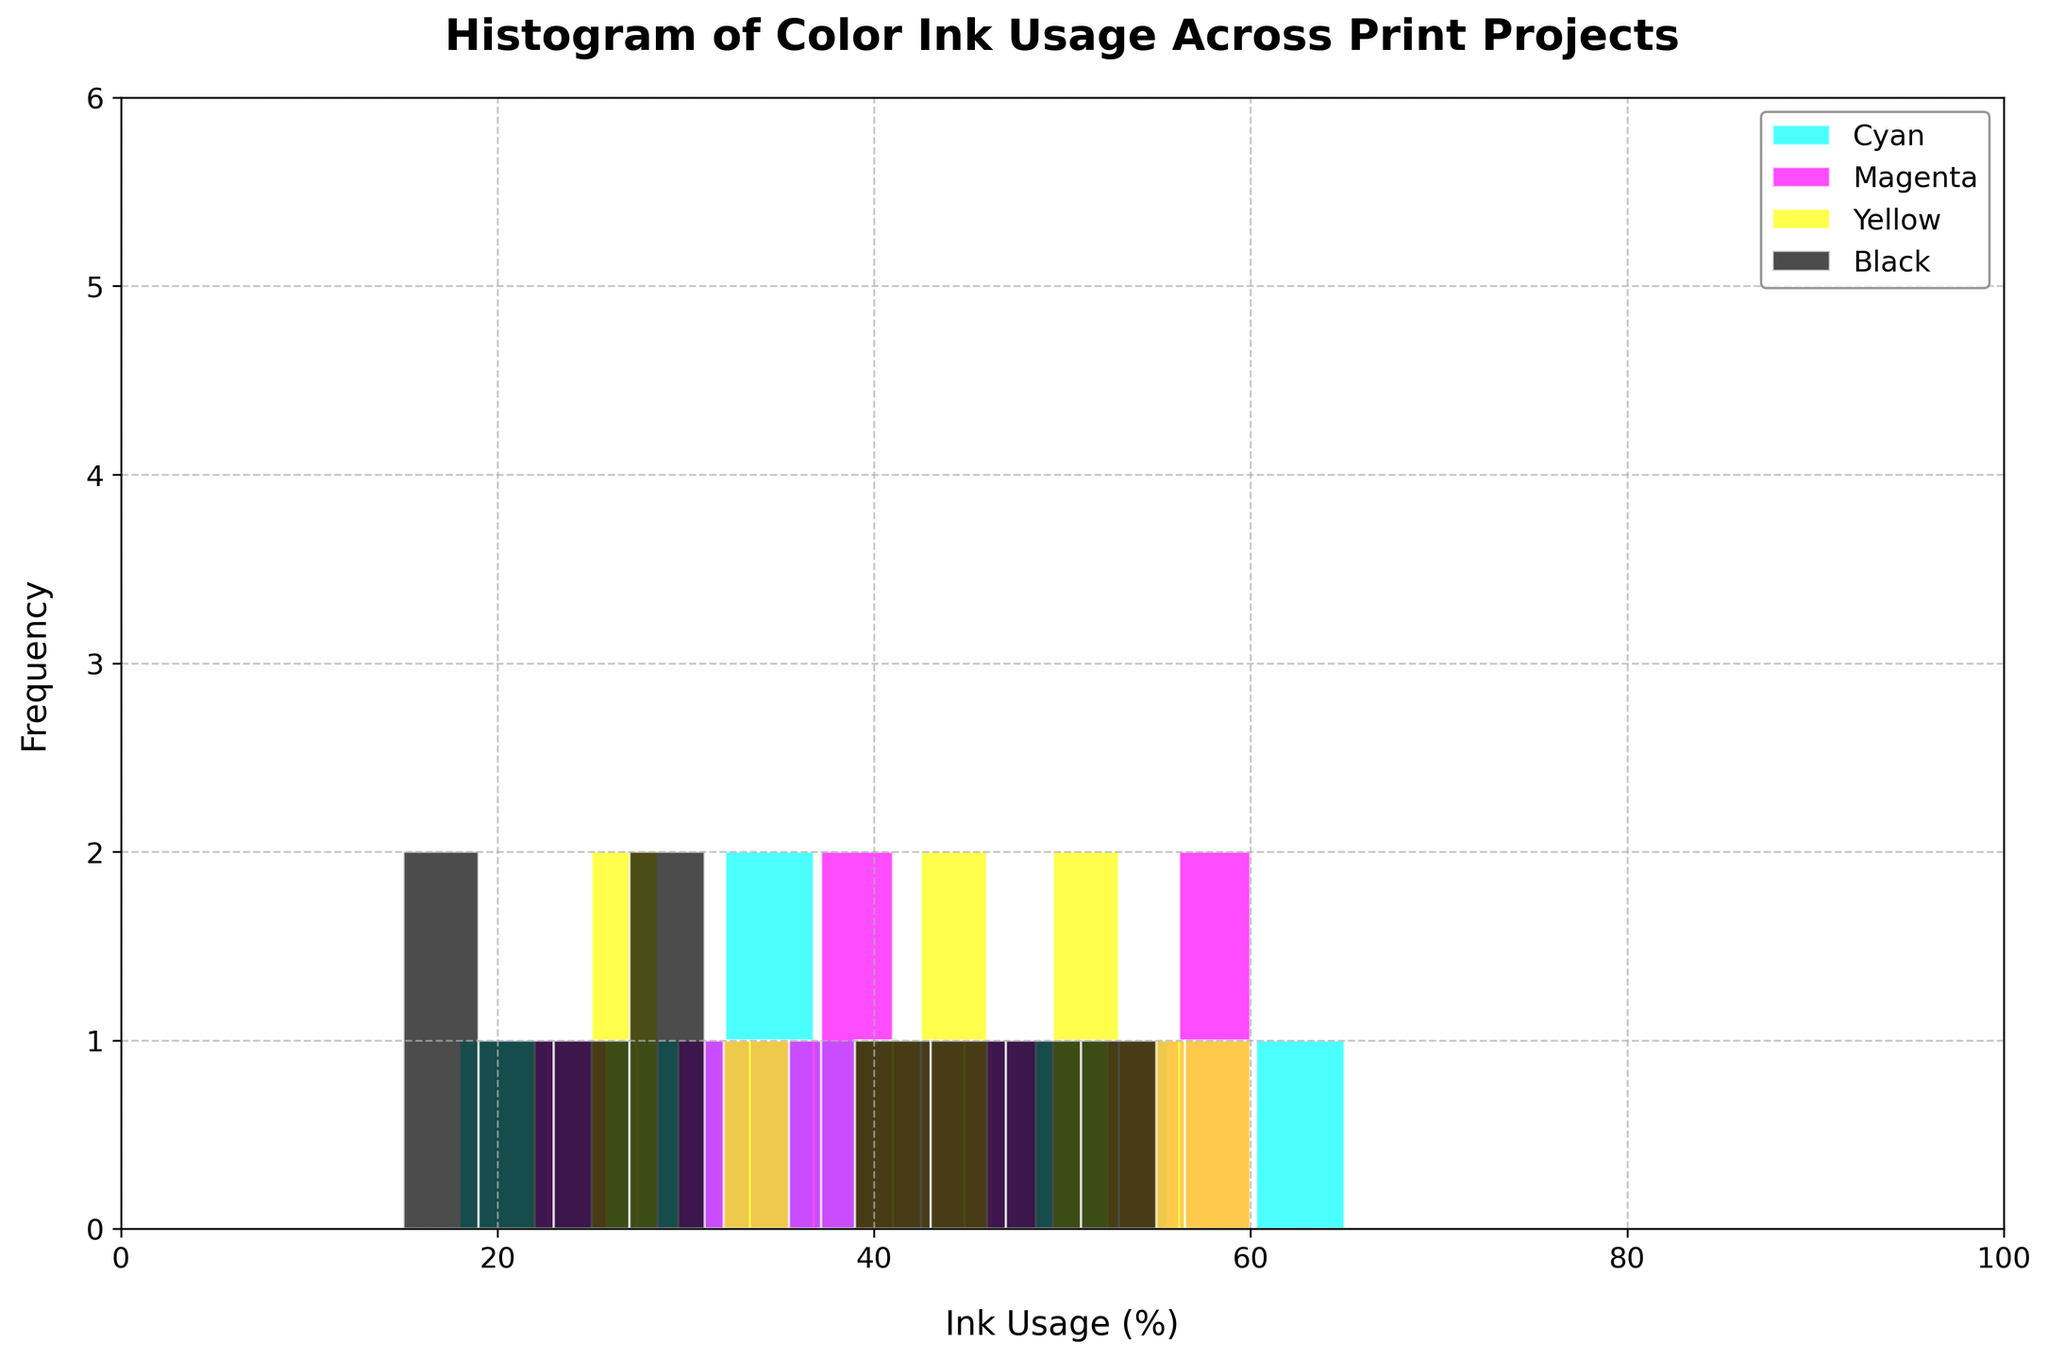What is the title of the histogram? The title of the histogram is written at the top of the figure in bold text.
Answer: Histogram of Color Ink Usage Across Print Projects What is the color of the histogram that represents magenta ink usage? The color of the histogram representing magenta ink usage is labeled in the legend on the upper right and visually identified in the plot.
Answer: Magenta What is the range of ink usage percentages on the x-axis? The x-axis represents the ink usage percentages, with the range indicated from 0 to 100. This can be seen by looking at the limits of the x-axis.
Answer: 0 to 100 How many bins are used in each histogram? By observing the distribution and the number of rectangles (bins) along the x-axis for each color, we can count them.
Answer: 10 Which color has the highest frequency of ink usage between 40% and 50%? To determine which color has the highest frequency in this range, compare the heights of the histograms between 40% and 50% ink usage.
Answer: Yellow What is the typical ink usage frequency for cyan ink in the 20%-30% range? Examine the height of the cyan histogram bars in the 20%-30% interval on the x-axis to identify its frequency.
Answer: 1 Which ink color shows the highest single frequency value, and what is that value? By inspecting the histograms, identify the tallest bar and note its color and corresponding frequency.
Answer: Black, 55% What is the combined frequency of cyan and yellow inks in the 30%-40% range? Add the heights of the cyan and yellow histogram bars within the 30%-40% range.
Answer: 2 In which range does black ink have its peak frequency, and what is this frequency? Find the tallest histogram bar for black ink and note its position on the x-axis and its height.
Answer: 45%-55%, 50 